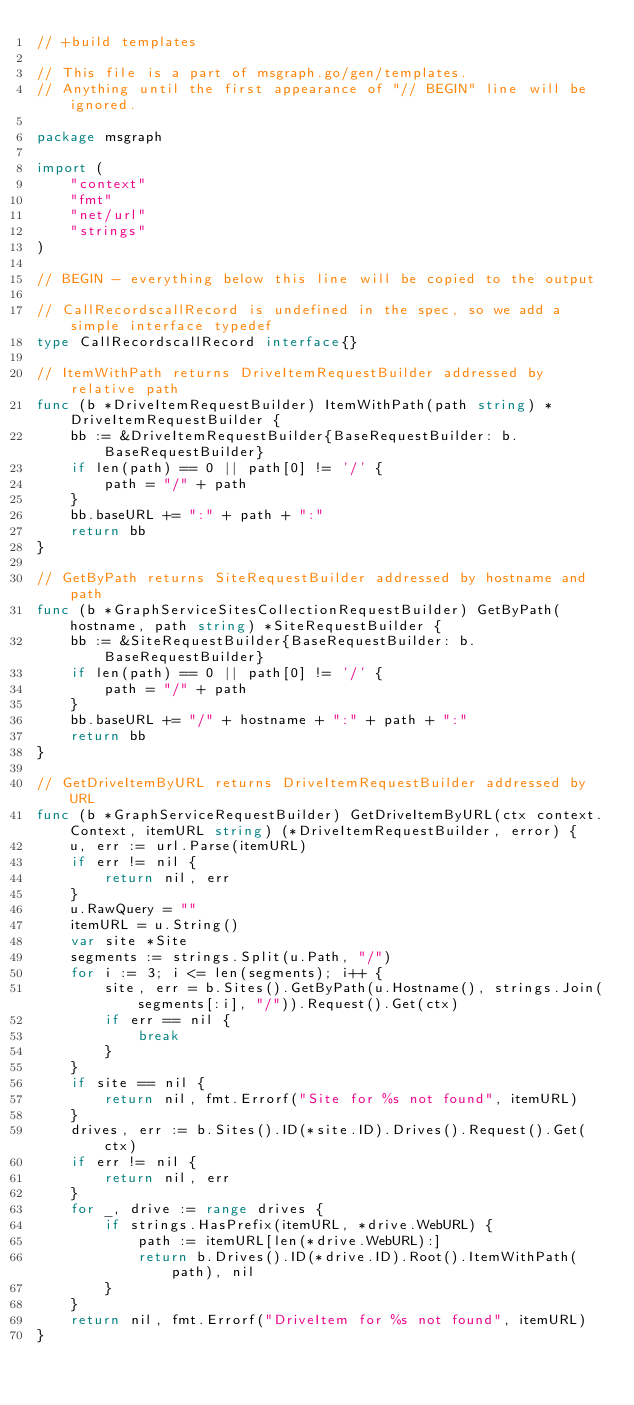Convert code to text. <code><loc_0><loc_0><loc_500><loc_500><_Go_>// +build templates

// This file is a part of msgraph.go/gen/templates.
// Anything until the first appearance of "// BEGIN" line will be ignored.

package msgraph

import (
	"context"
	"fmt"
	"net/url"
	"strings"
)

// BEGIN - everything below this line will be copied to the output

// CallRecordscallRecord is undefined in the spec, so we add a simple interface typedef
type CallRecordscallRecord interface{}

// ItemWithPath returns DriveItemRequestBuilder addressed by relative path
func (b *DriveItemRequestBuilder) ItemWithPath(path string) *DriveItemRequestBuilder {
	bb := &DriveItemRequestBuilder{BaseRequestBuilder: b.BaseRequestBuilder}
	if len(path) == 0 || path[0] != '/' {
		path = "/" + path
	}
	bb.baseURL += ":" + path + ":"
	return bb
}

// GetByPath returns SiteRequestBuilder addressed by hostname and path
func (b *GraphServiceSitesCollectionRequestBuilder) GetByPath(hostname, path string) *SiteRequestBuilder {
	bb := &SiteRequestBuilder{BaseRequestBuilder: b.BaseRequestBuilder}
	if len(path) == 0 || path[0] != '/' {
		path = "/" + path
	}
	bb.baseURL += "/" + hostname + ":" + path + ":"
	return bb
}

// GetDriveItemByURL returns DriveItemRequestBuilder addressed by URL
func (b *GraphServiceRequestBuilder) GetDriveItemByURL(ctx context.Context, itemURL string) (*DriveItemRequestBuilder, error) {
	u, err := url.Parse(itemURL)
	if err != nil {
		return nil, err
	}
	u.RawQuery = ""
	itemURL = u.String()
	var site *Site
	segments := strings.Split(u.Path, "/")
	for i := 3; i <= len(segments); i++ {
		site, err = b.Sites().GetByPath(u.Hostname(), strings.Join(segments[:i], "/")).Request().Get(ctx)
		if err == nil {
			break
		}
	}
	if site == nil {
		return nil, fmt.Errorf("Site for %s not found", itemURL)
	}
	drives, err := b.Sites().ID(*site.ID).Drives().Request().Get(ctx)
	if err != nil {
		return nil, err
	}
	for _, drive := range drives {
		if strings.HasPrefix(itemURL, *drive.WebURL) {
			path := itemURL[len(*drive.WebURL):]
			return b.Drives().ID(*drive.ID).Root().ItemWithPath(path), nil
		}
	}
	return nil, fmt.Errorf("DriveItem for %s not found", itemURL)
}
</code> 